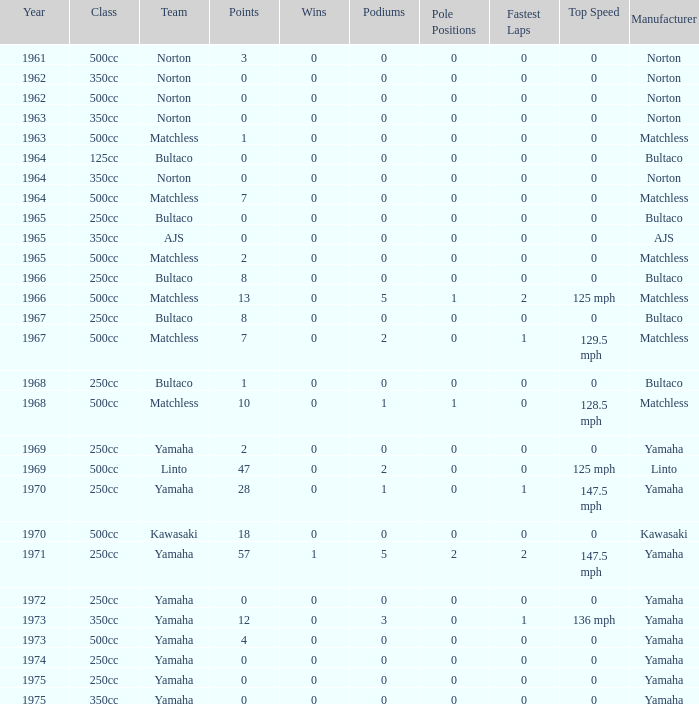What is the average wins in 250cc class for Bultaco with 8 points later than 1966? 0.0. 